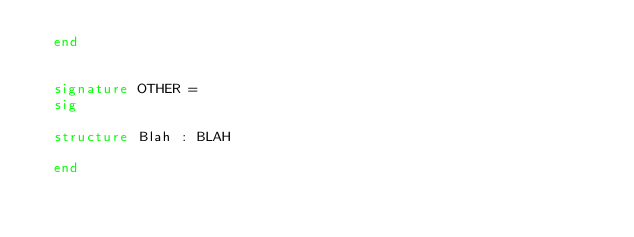Convert code to text. <code><loc_0><loc_0><loc_500><loc_500><_SML_>  end


  signature OTHER =
  sig

  structure Blah : BLAH
  
  end
</code> 